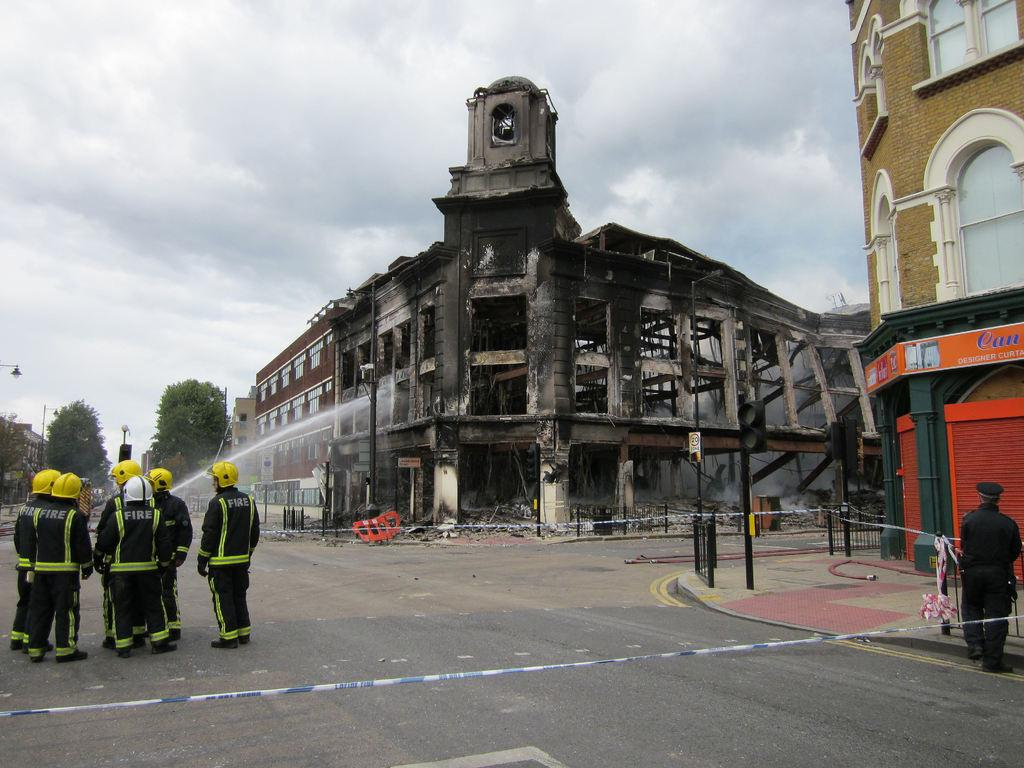What type of structures can be seen in the image? There are buildings and stores in the image. What is used to control traffic in the image? There is a traffic signal in the image. What type of barrier is present in the image? There is fencing in the image. What are the vertical supports in the image used for? The poles in the image are used to hold up various objects, such as signs or wires. What type of vegetation is present in the image? There are trees in the image. What type of lighting is present in the image? There are light poles in the image. Are there any people visible in the image? Yes, there are people standing in the image. What is the color of the sky in the image? The sky is in white and blue color in the image. Where is the straw located in the image? There is no straw present in the image. What type of pipe can be seen connecting the buildings in the image? There are no pipes connecting the buildings in the image. 